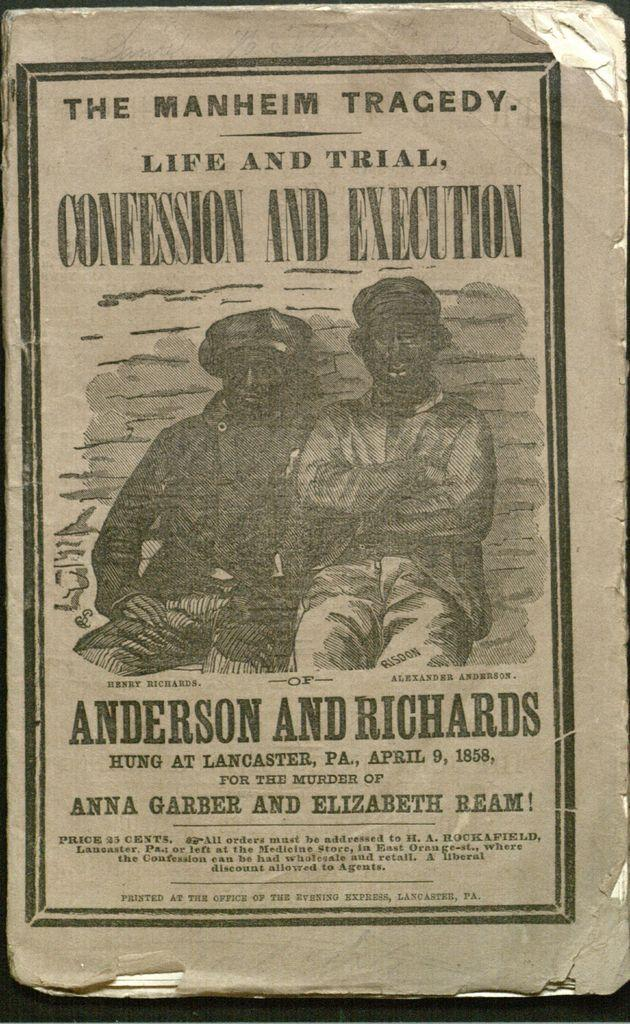What type of object is featured on the cover of the book in the image? The image contains the cover of an old book. What type of mint can be seen growing on the cover of the book in the image? There is no mint present on the cover of the book in the image. 